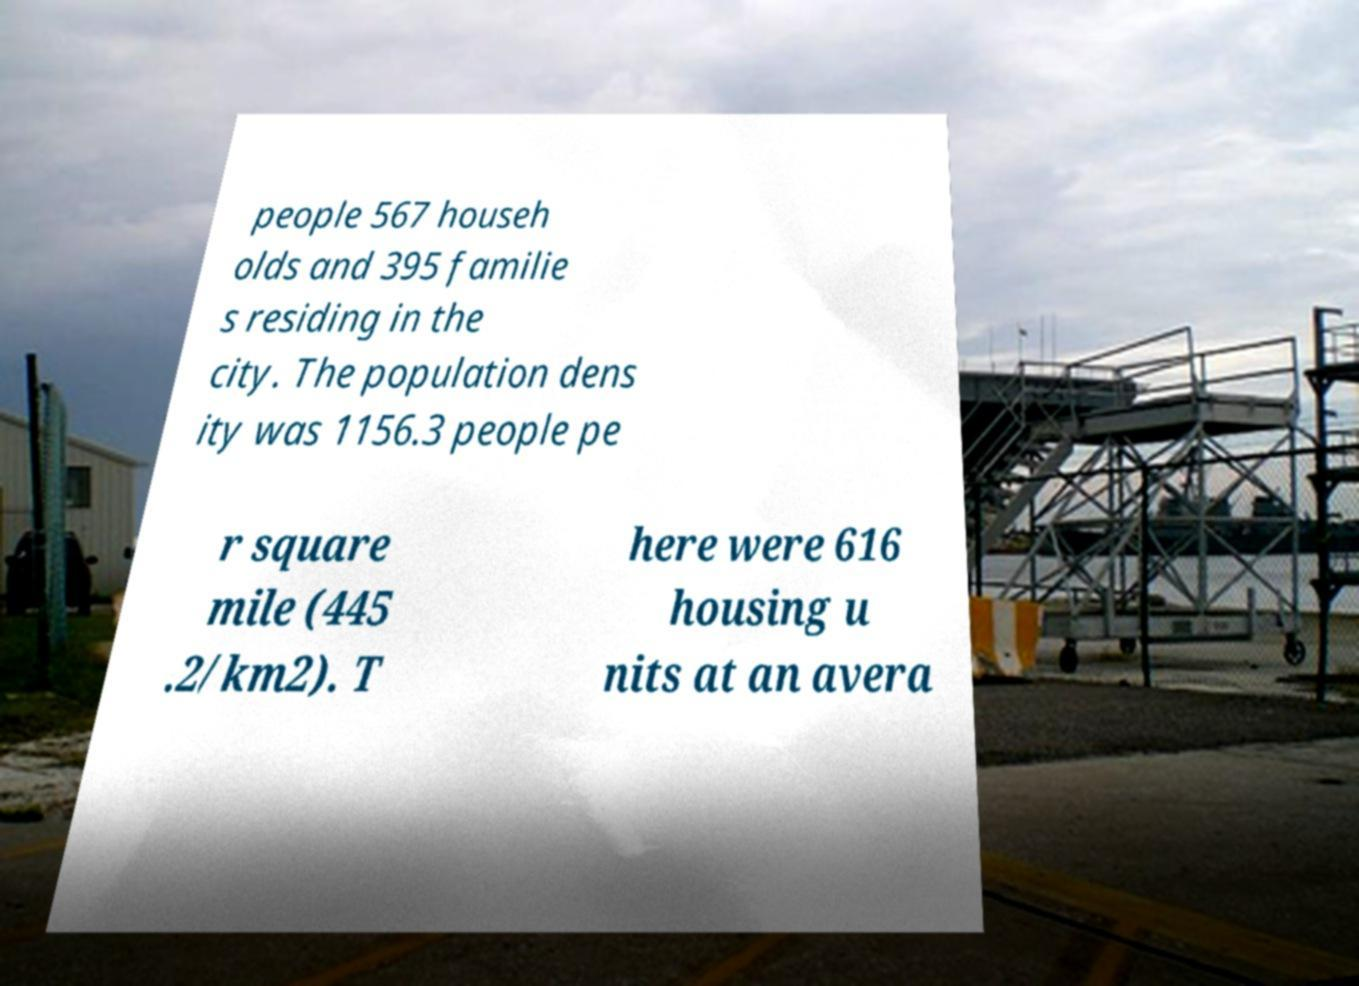Could you assist in decoding the text presented in this image and type it out clearly? people 567 househ olds and 395 familie s residing in the city. The population dens ity was 1156.3 people pe r square mile (445 .2/km2). T here were 616 housing u nits at an avera 